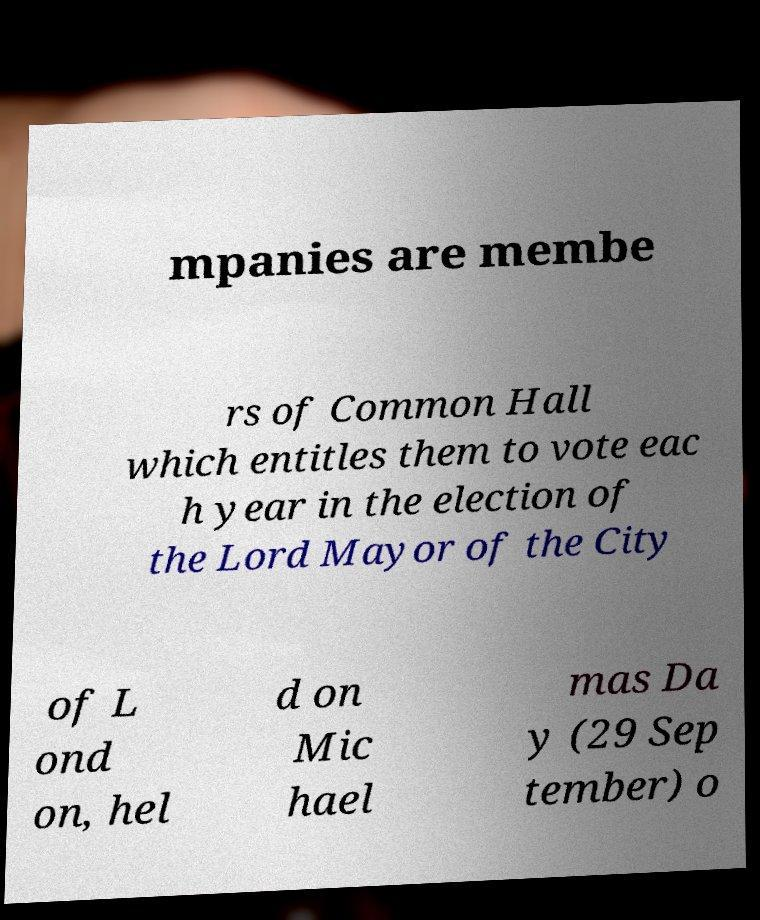Please read and relay the text visible in this image. What does it say? mpanies are membe rs of Common Hall which entitles them to vote eac h year in the election of the Lord Mayor of the City of L ond on, hel d on Mic hael mas Da y (29 Sep tember) o 